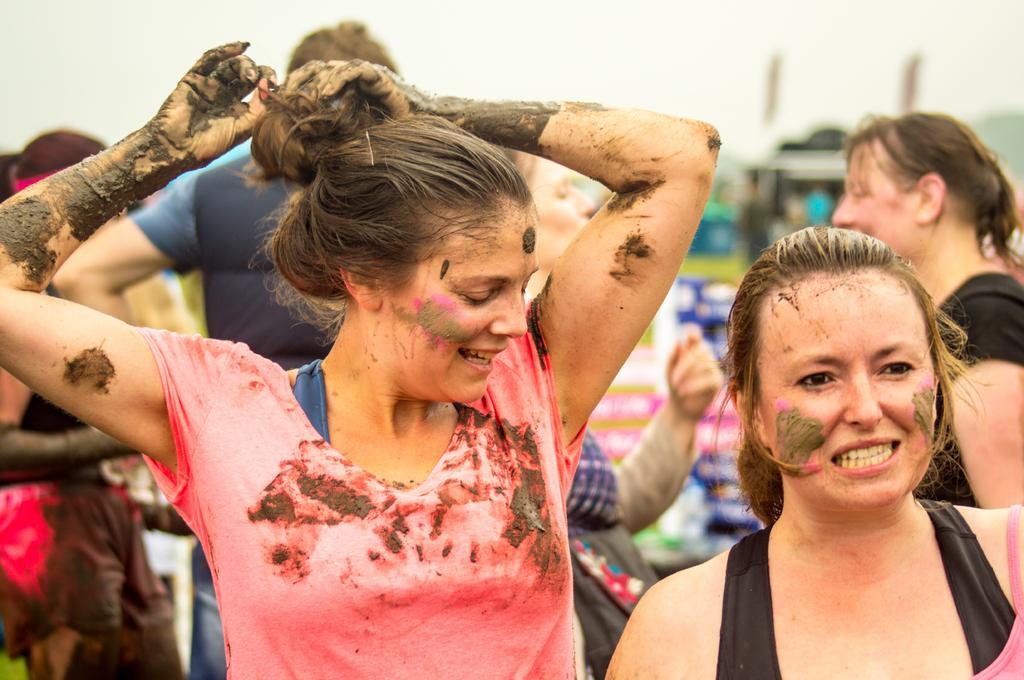Can you describe this image briefly? In the center of the image there is a lady with mud in her hands. To the right side of the image there is another lady. In the background of the image there are people and sky. 